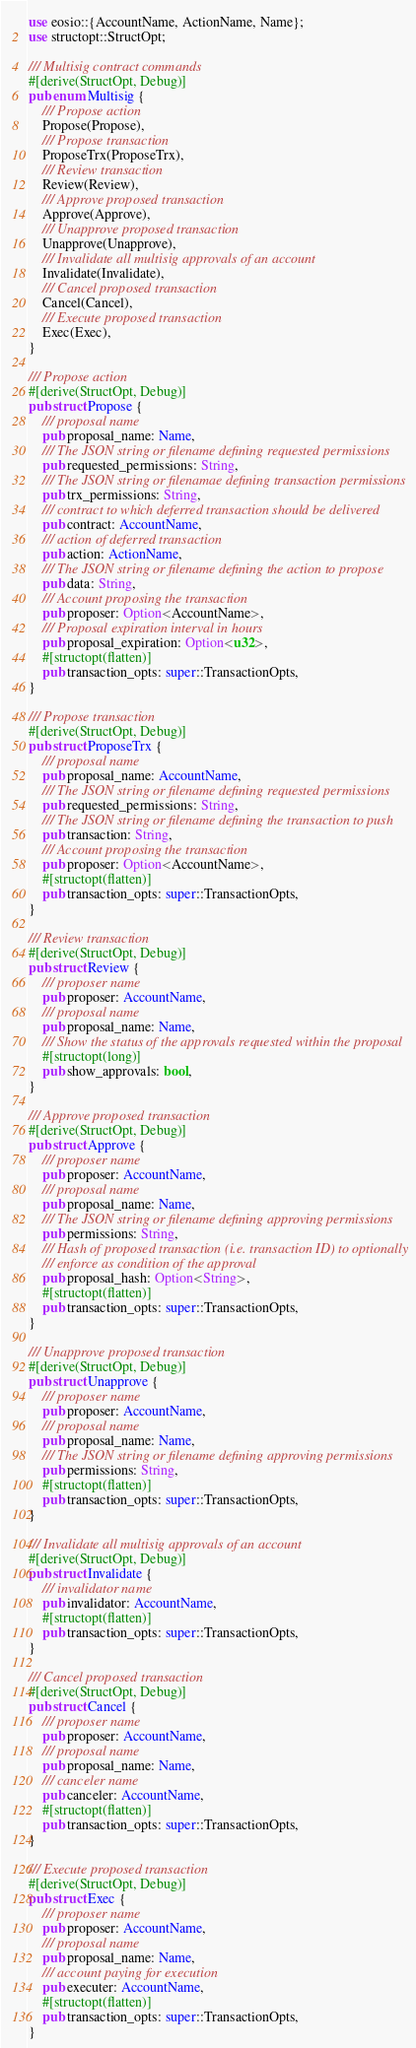Convert code to text. <code><loc_0><loc_0><loc_500><loc_500><_Rust_>use eosio::{AccountName, ActionName, Name};
use structopt::StructOpt;

/// Multisig contract commands
#[derive(StructOpt, Debug)]
pub enum Multisig {
    /// Propose action
    Propose(Propose),
    /// Propose transaction
    ProposeTrx(ProposeTrx),
    /// Review transaction
    Review(Review),
    /// Approve proposed transaction
    Approve(Approve),
    /// Unapprove proposed transaction
    Unapprove(Unapprove),
    /// Invalidate all multisig approvals of an account
    Invalidate(Invalidate),
    /// Cancel proposed transaction
    Cancel(Cancel),
    /// Execute proposed transaction
    Exec(Exec),
}

/// Propose action
#[derive(StructOpt, Debug)]
pub struct Propose {
    /// proposal name
    pub proposal_name: Name,
    /// The JSON string or filename defining requested permissions
    pub requested_permissions: String,
    /// The JSON string or filenamae defining transaction permissions
    pub trx_permissions: String,
    /// contract to which deferred transaction should be delivered
    pub contract: AccountName,
    /// action of deferred transaction
    pub action: ActionName,
    /// The JSON string or filename defining the action to propose
    pub data: String,
    /// Account proposing the transaction
    pub proposer: Option<AccountName>,
    /// Proposal expiration interval in hours
    pub proposal_expiration: Option<u32>,
    #[structopt(flatten)]
    pub transaction_opts: super::TransactionOpts,
}

/// Propose transaction
#[derive(StructOpt, Debug)]
pub struct ProposeTrx {
    /// proposal name
    pub proposal_name: AccountName,
    /// The JSON string or filename defining requested permissions
    pub requested_permissions: String,
    /// The JSON string or filename defining the transaction to push
    pub transaction: String,
    /// Account proposing the transaction
    pub proposer: Option<AccountName>,
    #[structopt(flatten)]
    pub transaction_opts: super::TransactionOpts,
}

/// Review transaction
#[derive(StructOpt, Debug)]
pub struct Review {
    /// proposer name
    pub proposer: AccountName,
    /// proposal name
    pub proposal_name: Name,
    /// Show the status of the approvals requested within the proposal
    #[structopt(long)]
    pub show_approvals: bool,
}

/// Approve proposed transaction
#[derive(StructOpt, Debug)]
pub struct Approve {
    /// proposer name
    pub proposer: AccountName,
    /// proposal name
    pub proposal_name: Name,
    /// The JSON string or filename defining approving permissions
    pub permissions: String,
    /// Hash of proposed transaction (i.e. transaction ID) to optionally
    /// enforce as condition of the approval
    pub proposal_hash: Option<String>,
    #[structopt(flatten)]
    pub transaction_opts: super::TransactionOpts,
}

/// Unapprove proposed transaction
#[derive(StructOpt, Debug)]
pub struct Unapprove {
    /// proposer name
    pub proposer: AccountName,
    /// proposal name
    pub proposal_name: Name,
    /// The JSON string or filename defining approving permissions
    pub permissions: String,
    #[structopt(flatten)]
    pub transaction_opts: super::TransactionOpts,
}

/// Invalidate all multisig approvals of an account
#[derive(StructOpt, Debug)]
pub struct Invalidate {
    /// invalidator name
    pub invalidator: AccountName,
    #[structopt(flatten)]
    pub transaction_opts: super::TransactionOpts,
}

/// Cancel proposed transaction
#[derive(StructOpt, Debug)]
pub struct Cancel {
    /// proposer name
    pub proposer: AccountName,
    /// proposal name
    pub proposal_name: Name,
    /// canceler name
    pub canceler: AccountName,
    #[structopt(flatten)]
    pub transaction_opts: super::TransactionOpts,
}

/// Execute proposed transaction
#[derive(StructOpt, Debug)]
pub struct Exec {
    /// proposer name
    pub proposer: AccountName,
    /// proposal name
    pub proposal_name: Name,
    /// account paying for execution
    pub executer: AccountName,
    #[structopt(flatten)]
    pub transaction_opts: super::TransactionOpts,
}
</code> 